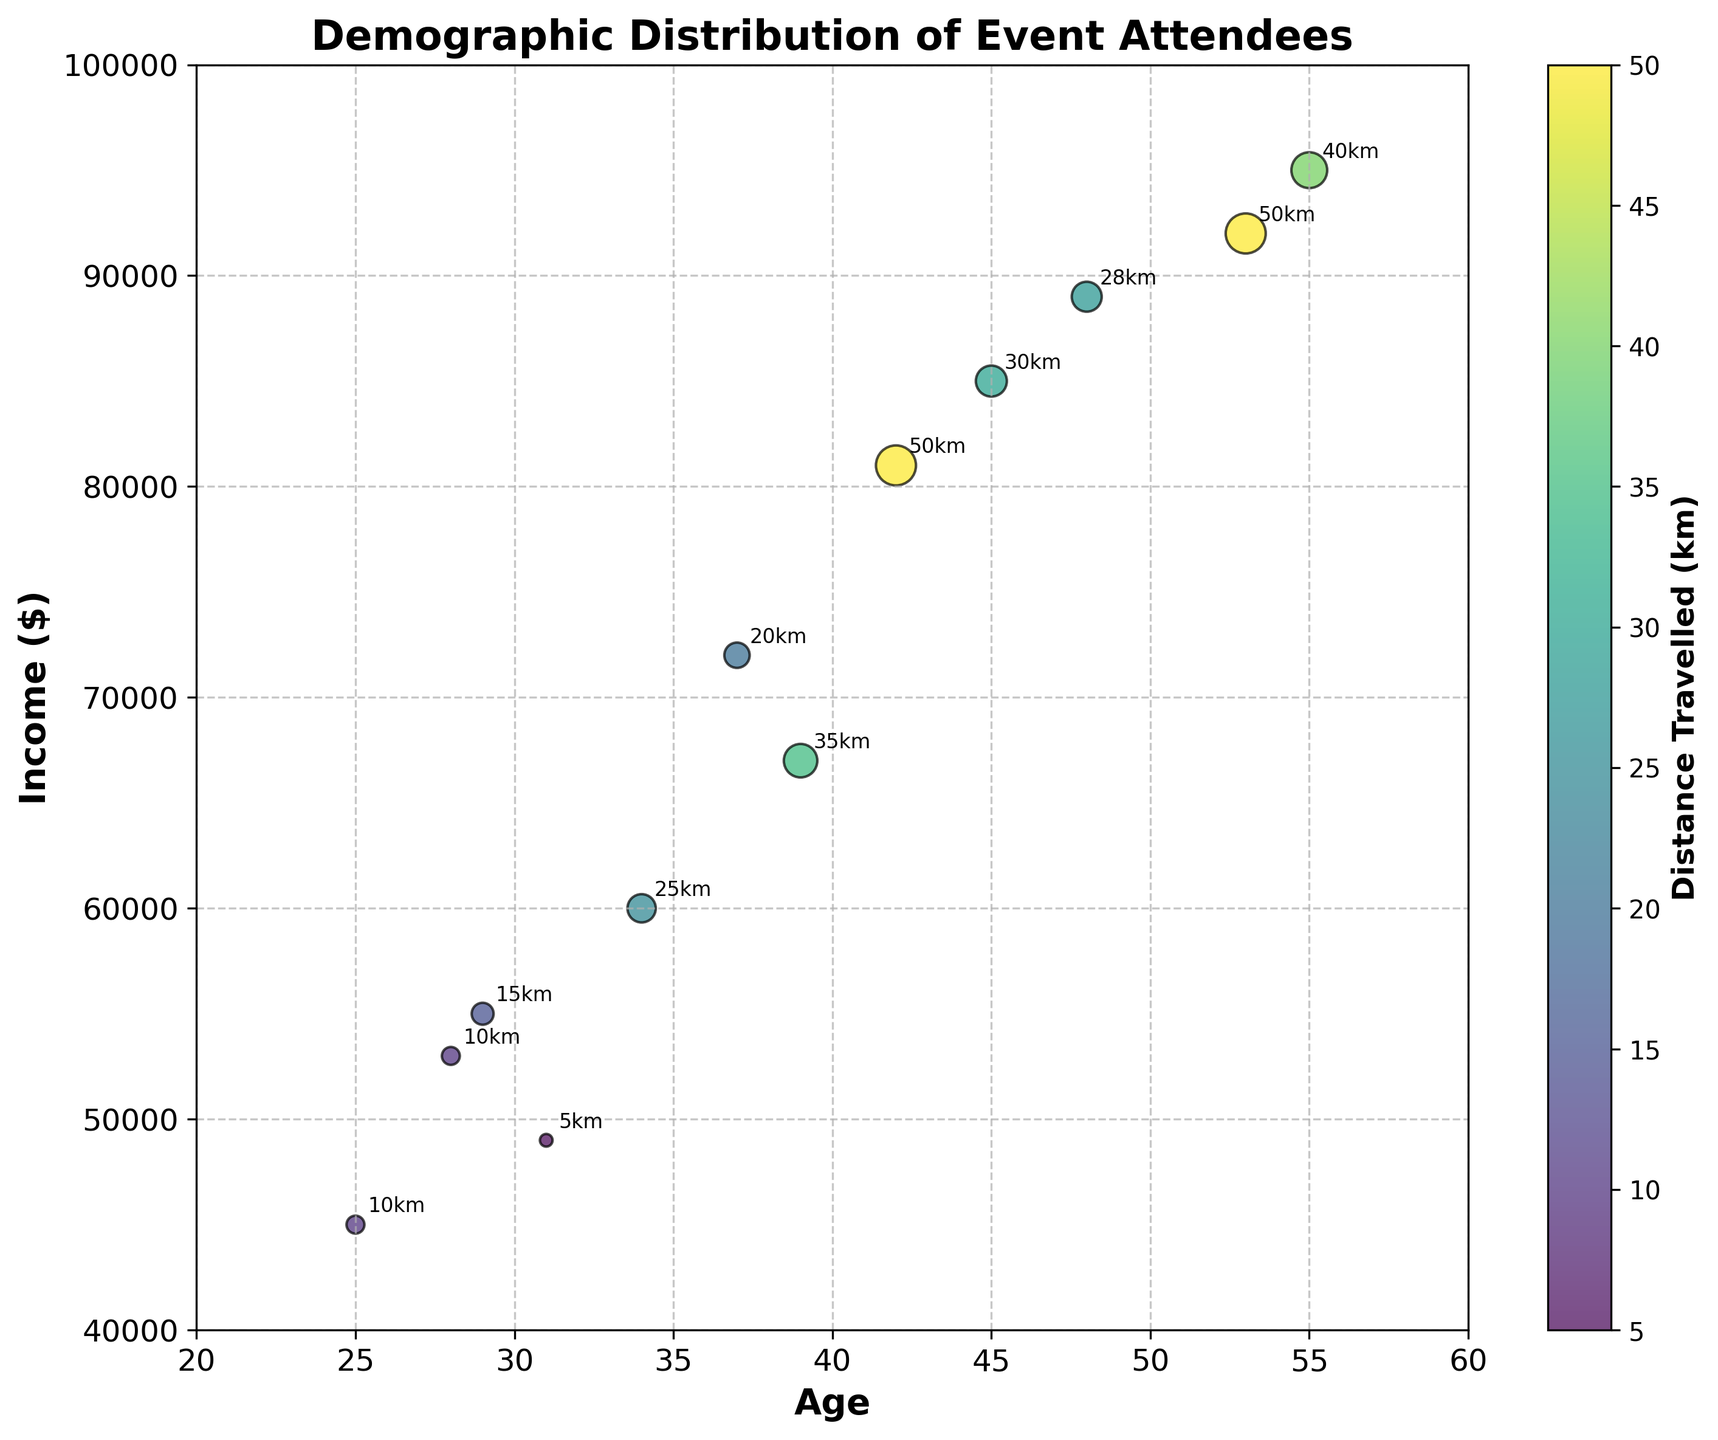What is the title of the figure? The title of the figure is shown at the top and in bold text. It reads "Demographic Distribution of Event Attendees".
Answer: Demographic Distribution of Event Attendees How many data points are plotted on the chart? By counting each bubble on the chart, we see there are 12 distinct points representing different attendees.
Answer: 12 What is the age range of the attendees? The x-axis represents the age of the attendees, starting from 20 to 60. The ages of the individual data points range from 25 to 55.
Answer: 25 to 55 Which attendee traveled the farthest distance? The color bar indicates the distance travelled. The darkest shade of the color bar corresponds to the farthest distance traveled. The darkest bubble is associated with an age of 42 and income of $81,000. From the annotated text, this distance is 50 km.
Answer: The attendee aged 42 with an income of $81,000 What is the average income of all attendees? By summing up all incomes and dividing by the number of data points: (45000 + 60000 + 81000 + 55000 + 49000 + 72000 + 85000 + 95000 + 53000 + 67000 + 89000 + 92000)/12 = 68,167
Answer: 68,167 What is the median age of the attendees? To find the median age, we first list the ages in ascending order: 25, 28, 29, 31, 34, 37, 39, 42, 45, 48, 53, 55. The median is the middle value, which is the average of the 6th and 7th values: (37 + 39) / 2 = 38
Answer: 38 What is the relationship between income and distance traveled in this plot? Observing the figure, we note that higher incomes generally correspond to higher distances traveled, as indicated by larger and darker bubbles in the upper part of the plot.
Answer: Positive correlation Which age group has the most diverse range of incomes? By identifying the spread of incomes across various age groups, the age group 39 seems to have the widest range of incomes, as seen by the wide spread of income values depicted for people aged similar to 39 years.
Answer: 39 years Compare the income of the attendees aged 31 and 37. Who has a higher income? By looking at the y-axis values, the income for the attendee aged 31 is $49,000, whereas the income for the attendee aged 37 is $72,000.
Answer: The attendee aged 37 How does the distance travelled by the eldest attendee compare to the youngest attendee? The eldest attendee is 55 years old and traveled 40 km, while the youngest is 25 years old and traveled 10 km. Therefore, the eldest traveled 30 km more.
Answer: 30 km more 